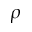<formula> <loc_0><loc_0><loc_500><loc_500>\rho</formula> 